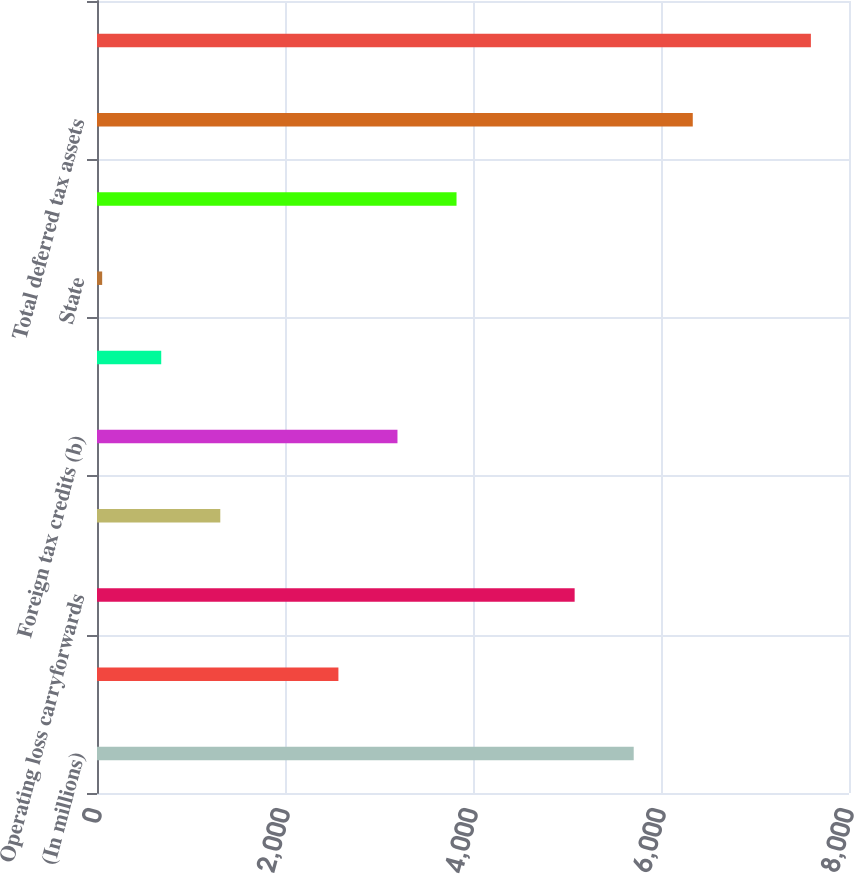<chart> <loc_0><loc_0><loc_500><loc_500><bar_chart><fcel>(In millions)<fcel>Employee benefits<fcel>Operating loss carryforwards<fcel>Derivative instruments<fcel>Foreign tax credits (b)<fcel>Other<fcel>State<fcel>Foreign (d)<fcel>Total deferred tax assets<fcel>Property plant and equipment<nl><fcel>5709.7<fcel>2568.2<fcel>5081.4<fcel>1311.6<fcel>3196.5<fcel>683.3<fcel>55<fcel>3824.8<fcel>6338<fcel>7594.6<nl></chart> 